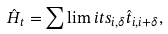<formula> <loc_0><loc_0><loc_500><loc_500>\hat { H } _ { t } = \sum \lim i t s _ { i , \delta } \hat { t } _ { i , i + \delta } ,</formula> 